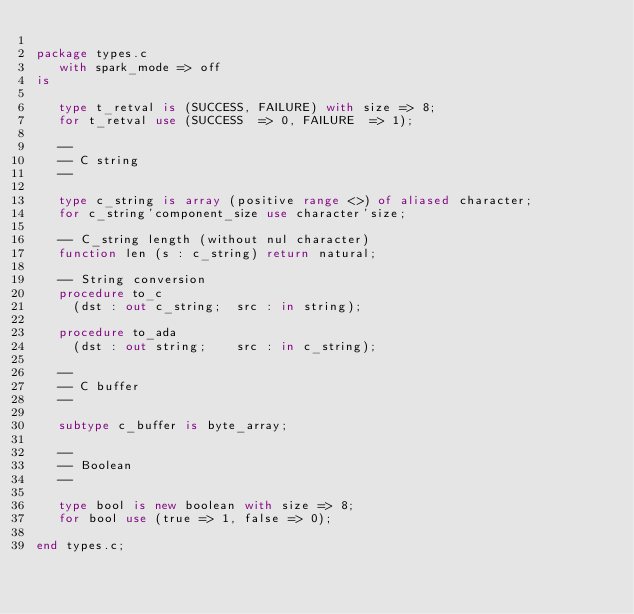<code> <loc_0><loc_0><loc_500><loc_500><_Ada_>
package types.c
   with spark_mode => off
is

   type t_retval is (SUCCESS, FAILURE) with size => 8;
   for t_retval use (SUCCESS  => 0, FAILURE  => 1);

   --
   -- C string
   --

   type c_string is array (positive range <>) of aliased character;
   for c_string'component_size use character'size;

   -- C_string length (without nul character)
   function len (s : c_string) return natural;

   -- String conversion
   procedure to_c
     (dst : out c_string;  src : in string);

   procedure to_ada
     (dst : out string;    src : in c_string);

   --
   -- C buffer
   --

   subtype c_buffer is byte_array;

   --
   -- Boolean
   --

   type bool is new boolean with size => 8;
   for bool use (true => 1, false => 0);

end types.c;
</code> 